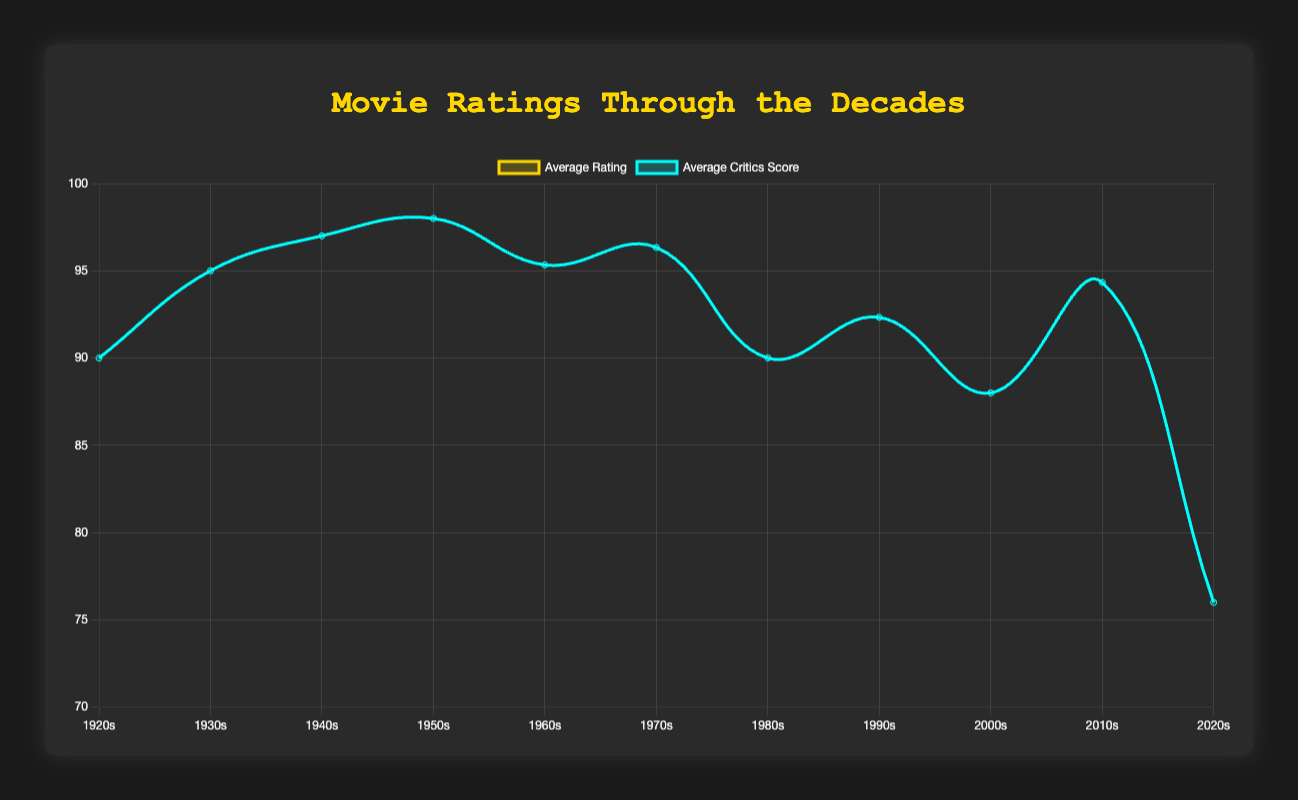How do the average ratings and critics' scores compare in the 1940s? For the 1940s, find the average rating and critics' score points on the plot and compare their values visually. The average rating is approximately 8.4, and the critics' score is around 97. The critics’ score is higher.
Answer: Critics’ score is higher What decade had the highest average critics' score? Look for the peak value on the critics' score line. The highest point occurs in the 1940s.
Answer: 1940s In which decade did the average rating reach its lowest value? Inspect the plot for the lowest point on the ratings line. The 2020s have the lowest average rating.
Answer: 2020s What's the average rating difference between the 1950s and the 2000s? Locate the average ratings for the 1950s (8.5) and the 2000s (8.8) on the plot. Subtract the 1950s rating from the 2000s rating: 8.8 - 8.5 = 0.3.
Answer: 0.3 During which decade did the gap between average rating and critics' score seem the smallest? Identify the points where the two lines are closest together. The lines are closest together in the 1980s.
Answer: 1980s How do the critics' scores in the 1960s compare to those in the 1970s? Look for the average critics' score values on the plot for the 1960s (around 95) and the 1970s (around 96). The scores in the 1970s are slightly higher than those in the 1960s.
Answer: Scores in the 1970s are slightly higher Are there any decades where the average rating and critics' score both reach their respective peaks? Determine the highest points on both the rating and critics' score lines and see if they coincide. The 1940s show both the highest ratings and critics' scores.
Answer: 1940s What is the visual trend in average ratings from the 1920s to the 2020s? Observe the overall movement of the ratings line from left (1920s) to right (2020s). The ratings trend upward from the 1920s to 1950s, then fluctuate before declining in the 2020s.
Answer: Upward to declining trend By how much did the critics' score drop from the 2010s to the 2020s? Find the critics' scores for the 2010s (90) and 2020s (about 76) on the plot. Subtract the 2020s score from the 2010s score: 90 - 76 = 14.
Answer: 14 Which decade had the most balanced scores between ratings and critics' scores? Examine the plot for points where the average rating and critics' score lines are very close together. In the 1980s, the lines appear almost parallel and close together.
Answer: 1980s 